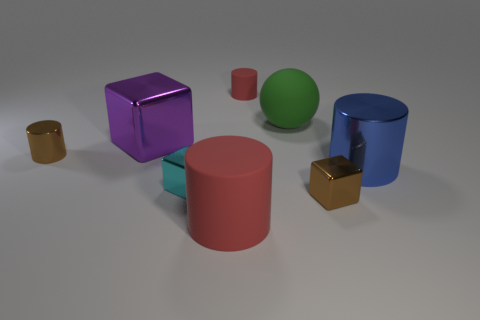What kind of lighting is used in the image? The image is illuminated with soft, diffused lighting that minimizes shadows and highlights the objects' colors. The lighting appears to be coming from above, creating a gentle ambiance and allowing the objects' textures and colors to be distinctly observed. 